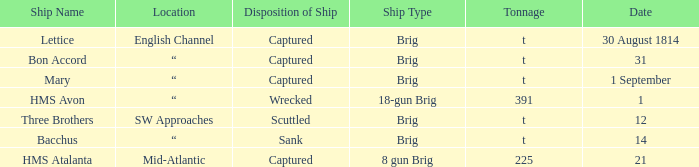With a tonnage of 225 what is the ship type? 8 gun Brig. 